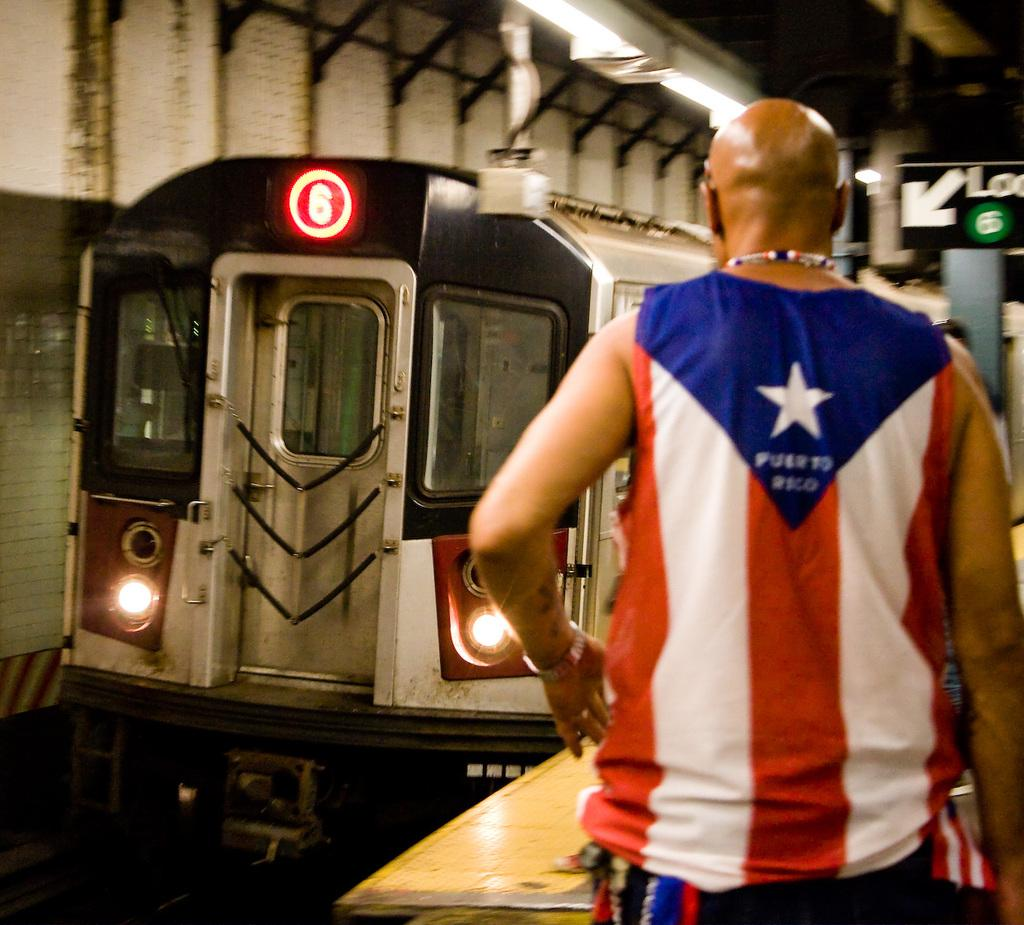Who or what is present in the image? There is a person in the image. What is the main object in the center of the image? There is a train in the center of the image. What can be seen on the right side of the image? There is a sign board on the right side of the image. What is visible at the top of the image? There are lights visible at the top of the image. What type of eggnog is being served in the image? There is no eggnog present in the image. What flag is being displayed in the image? There is no flag present in the image. 